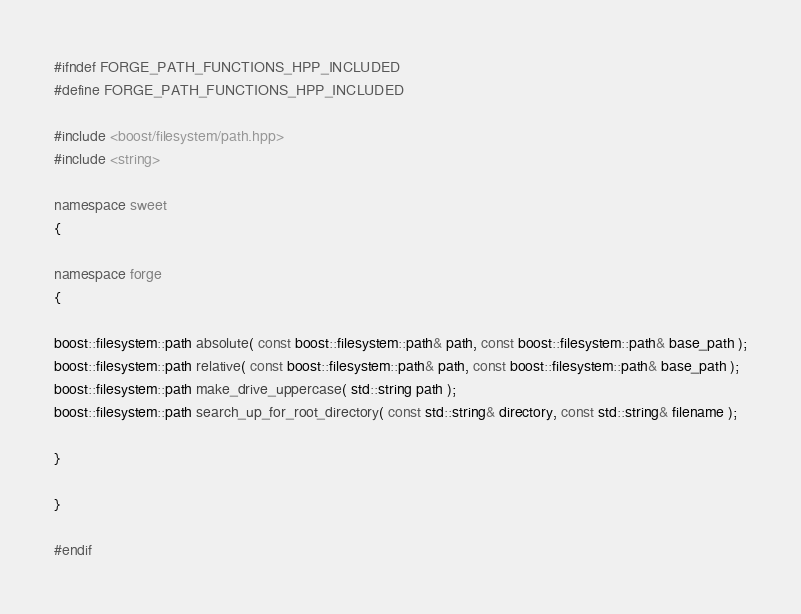Convert code to text. <code><loc_0><loc_0><loc_500><loc_500><_C++_>#ifndef FORGE_PATH_FUNCTIONS_HPP_INCLUDED
#define FORGE_PATH_FUNCTIONS_HPP_INCLUDED

#include <boost/filesystem/path.hpp>
#include <string>

namespace sweet
{

namespace forge
{

boost::filesystem::path absolute( const boost::filesystem::path& path, const boost::filesystem::path& base_path );
boost::filesystem::path relative( const boost::filesystem::path& path, const boost::filesystem::path& base_path );
boost::filesystem::path make_drive_uppercase( std::string path );
boost::filesystem::path search_up_for_root_directory( const std::string& directory, const std::string& filename );

}

}

#endif
</code> 